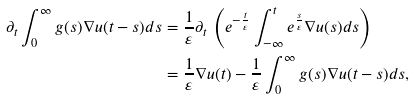Convert formula to latex. <formula><loc_0><loc_0><loc_500><loc_500>\partial _ { t } \int _ { 0 } ^ { \infty } g ( s ) \nabla u ( t - s ) d s & = \frac { 1 } { \varepsilon } \partial _ { t } \, \left ( e ^ { - \frac { t } \varepsilon } \int _ { - \infty } ^ { t } e ^ { \frac { s } \varepsilon } \nabla u ( s ) d s \right ) \\ & = \frac { 1 } { \varepsilon } \nabla u ( t ) - \frac { 1 } { \varepsilon } \int _ { 0 } ^ { \infty } g ( s ) \nabla u ( t - s ) d s ,</formula> 